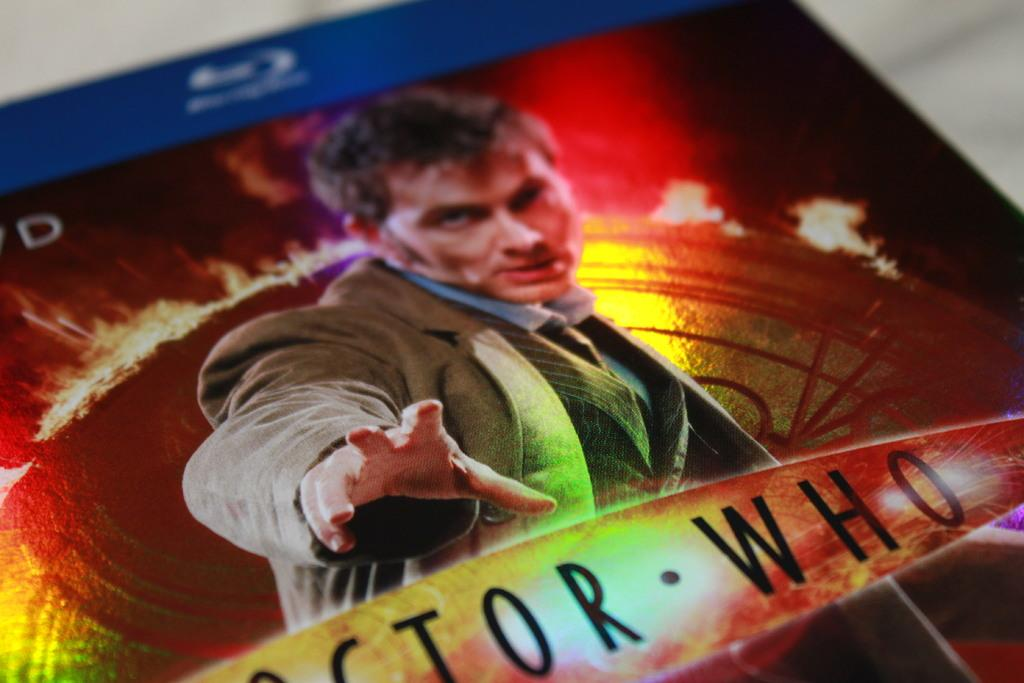<image>
Summarize the visual content of the image. A Blu Ray disc of the Doctor Who series with the character on the front 